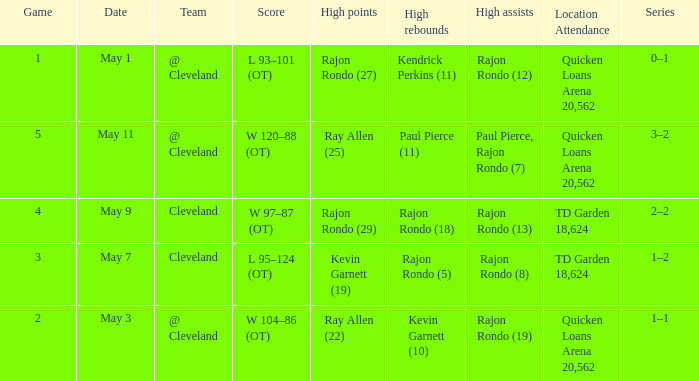Where does the team play May 3? @ Cleveland. 